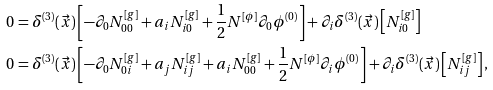<formula> <loc_0><loc_0><loc_500><loc_500>0 & = \delta ^ { ( 3 ) } ( \vec { x } ) \left [ - \partial _ { 0 } N ^ { [ g ] } _ { 0 0 } + a _ { i } N ^ { [ g ] } _ { i 0 } + \frac { 1 } { 2 } N ^ { [ \phi ] } \partial _ { 0 } \phi ^ { ( 0 ) } \right ] + \partial _ { i } \delta ^ { ( 3 ) } ( \vec { x } ) \left [ N ^ { [ g ] } _ { i 0 } \right ] \\ 0 & = \delta ^ { ( 3 ) } ( \vec { x } ) \left [ - \partial _ { 0 } N ^ { [ g ] } _ { 0 i } + a _ { j } N ^ { [ g ] } _ { i j } + a _ { i } N ^ { [ g ] } _ { 0 0 } + \frac { 1 } { 2 } N ^ { [ \phi ] } \partial _ { i } \phi ^ { ( 0 ) } \right ] + \partial _ { i } \delta ^ { ( 3 ) } ( \vec { x } ) \left [ N ^ { [ g ] } _ { i j } \right ] ,</formula> 